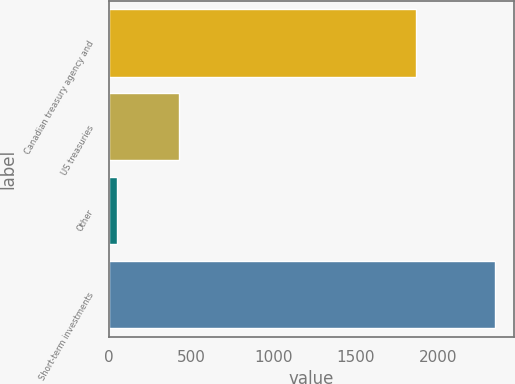<chart> <loc_0><loc_0><loc_500><loc_500><bar_chart><fcel>Canadian treasury agency and<fcel>US treasuries<fcel>Other<fcel>Short-term investments<nl><fcel>1865<fcel>429<fcel>49<fcel>2343<nl></chart> 